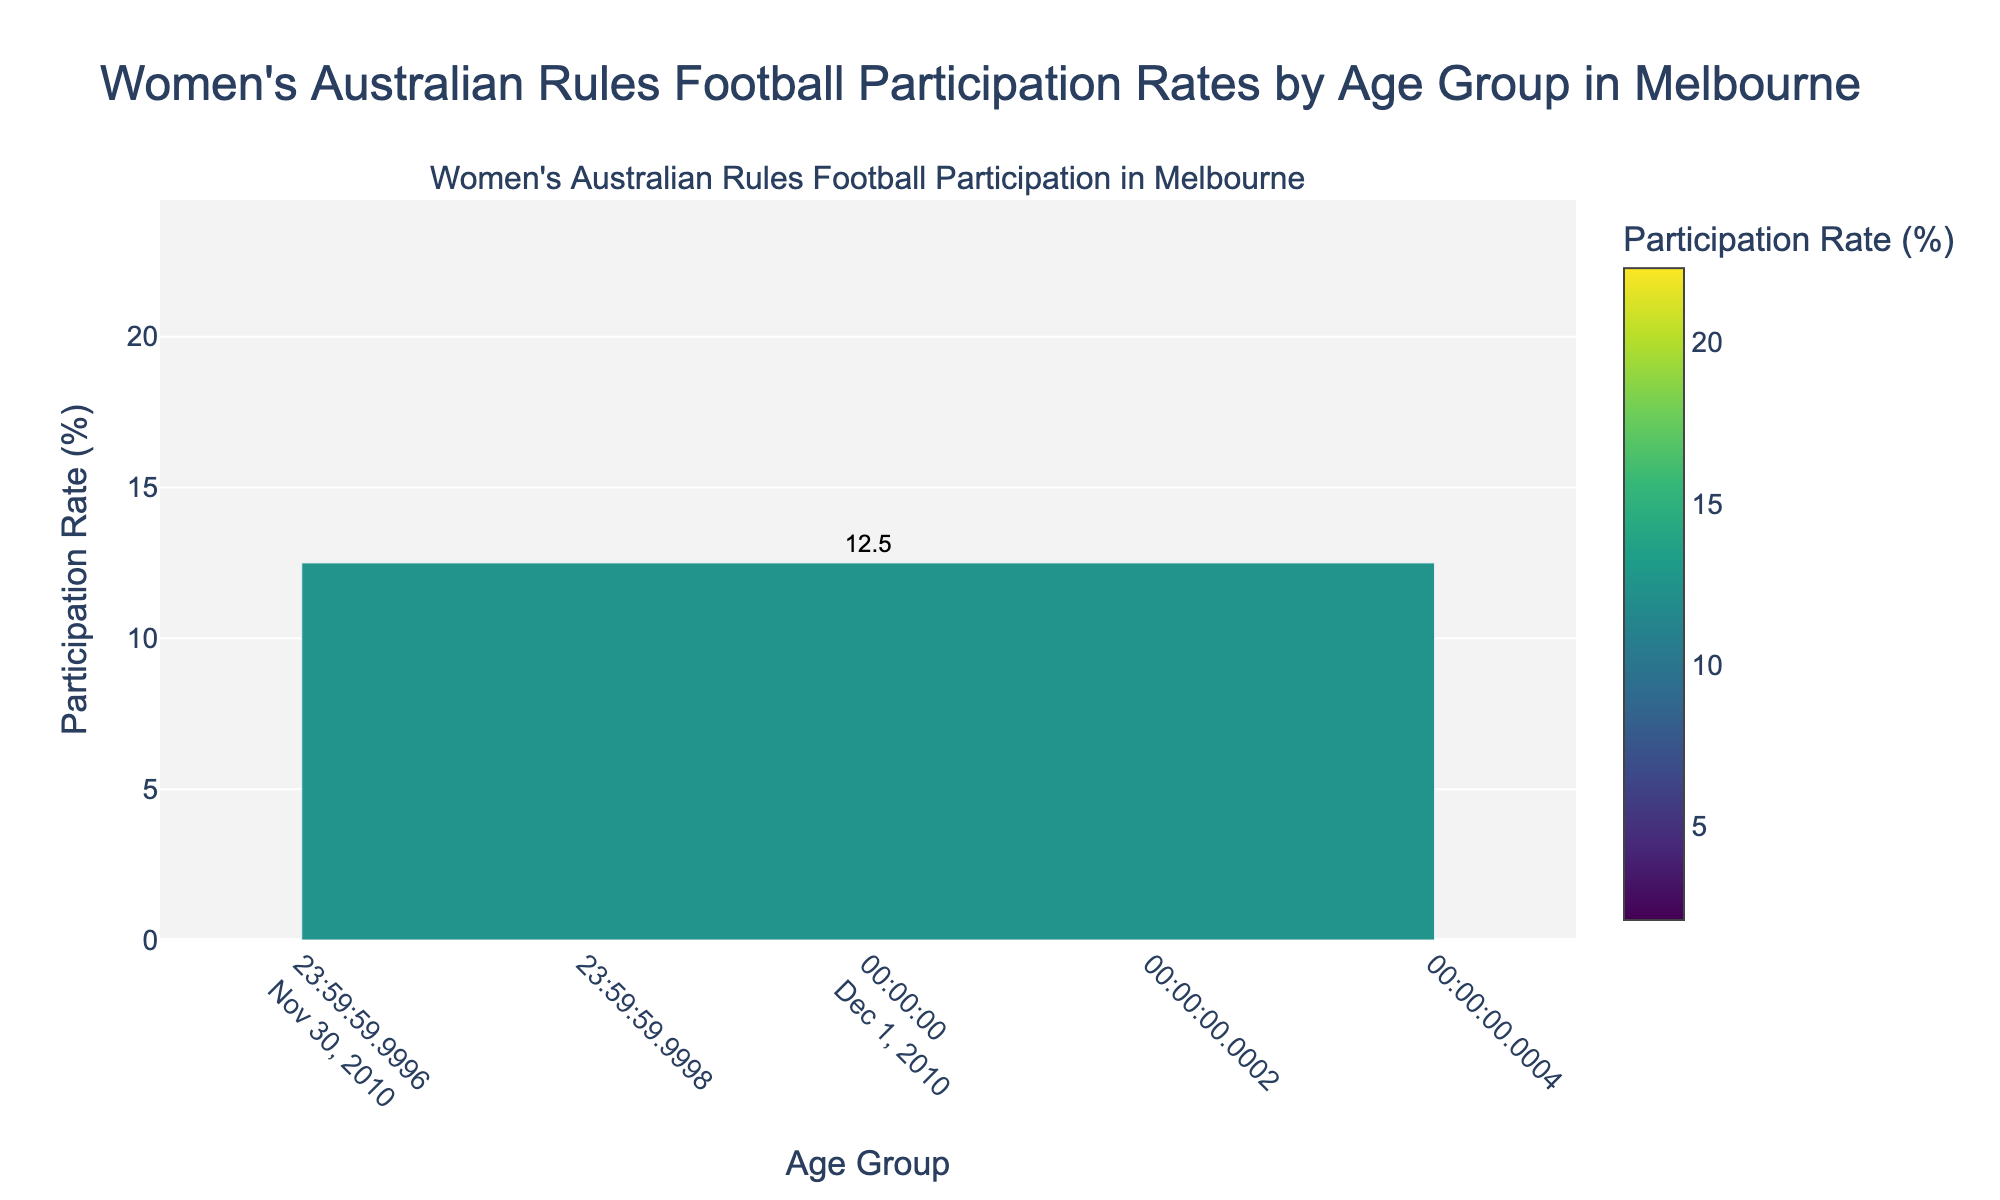What age group has the highest participation rate in women's Australian rules football? The figure shows the participation rates for each age group. By scanning the height of the bars, we see that the 16-18 age group has the highest participation rate.
Answer: 16-18 What is the participation rate difference between the 13-15 age group and the 22-25 age group? To find the difference, identify the participation rates for the two age groups. The 13-15 age group has 18.7%, and the 22-25 age group has 15.6%. Subtract 15.6 from 18.7.
Answer: 3.1% Which age group has a lower participation rate: 31-35 or 41-45? Compare the heights and values of the bars for these two age groups. The 31-35 age group has a participation rate of 9.4%, while the 41-45 age group has 5.3%.
Answer: 41-45 What is the average participation rate for the age groups under 10 and 10-12? Calculate the average by adding the participation rates for Under 10 (8.2%) and 10-12 (12.5%), then divide by 2. (8.2 + 12.5) / 2 = 10.35%
Answer: 10.35% How does the participation rate of the 19-21 age group compare to that of the 26-30 age group? Compare the heights and values of the bars. The 19-21 age group has a participation rate of 19.8%, while the 26-30 age group has 11.9%. 19.8% is higher than 11.9%.
Answer: 19-21 has a higher rate Which age groups have participation rates greater than 15%? Examine the bars and list all the age groups with participation rates exceeding 15%. These are 13-15 (18.7%), 16-18 (22.3%), and 19-21 (19.8%).
Answer: 13-15, 16-18, 19-21 How much higher is the participation rate of the 22-25 age group compared to the 31-35 age group? Find the rates for the 22-25 age group (15.6%) and the 31-35 group (9.4%) and subtract the second from the first. 15.6% - 9.4%
Answer: 6.2% What is the participation rate trend from ages 10-12 to 16-18? Observe the bars for the age groups 10-12, 13-15, and 16-18. The trend involves increasing bar heights and values: 10-12 (12.5%), 13-15 (18.7%), and 16-18 (22.3%).
Answer: Increasing Which age group has the least participation, and what is its rate? Identify the shortest bar in the figure. The "Over 50" age group has the lowest participation rate at 2.1%.
Answer: Over 50, 2.1% What is the combined participation rate for the age groups under 10 and 36-40? Sum the participation rates of Under 10 (8.2%) and 36-40 (7.1%). 8.2 + 7.1 = 15.3%
Answer: 15.3% 